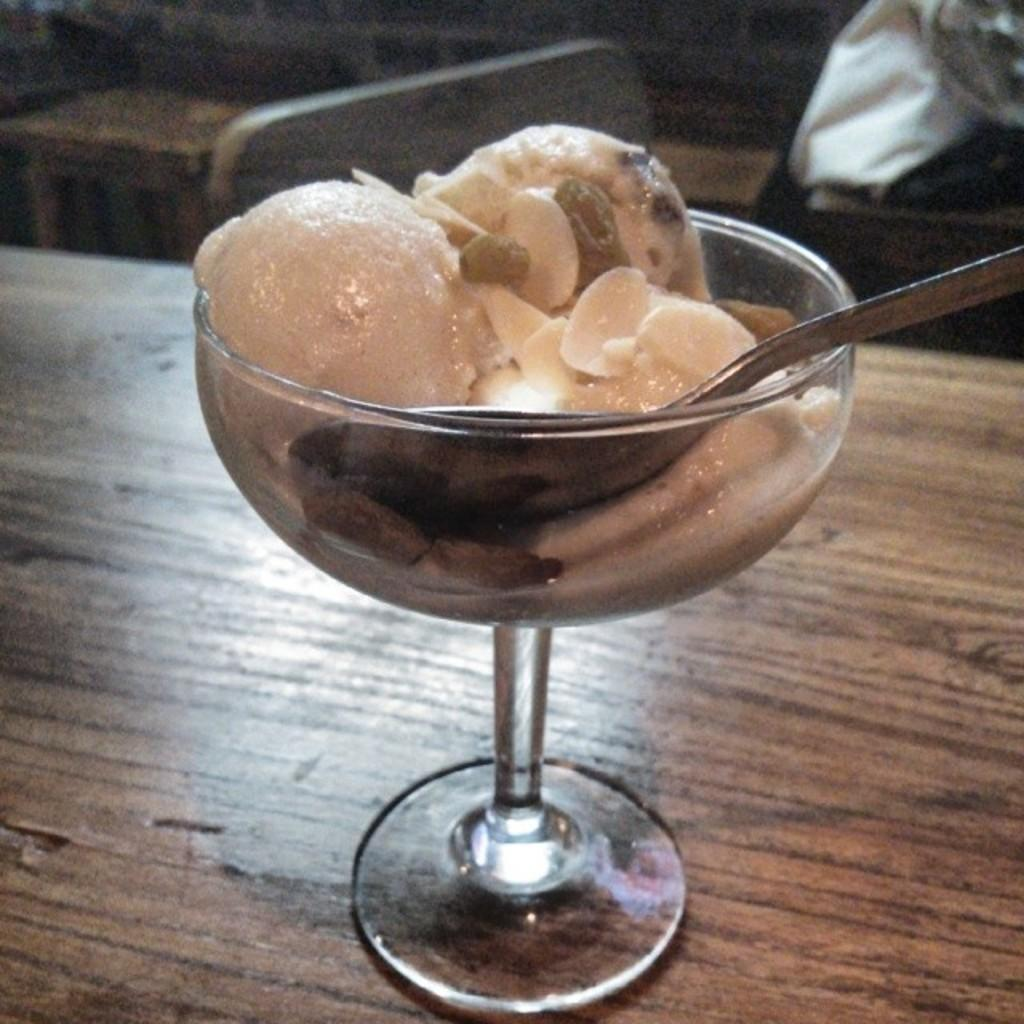What type of dessert is in the image? There is an ice cream in a cup in the image. What utensil is present in the image? There is a spoon in the image. On what surface is the ice cream and spoon placed? The ice cream and spoon are on a wooden table. What can be seen at the top of the image? There are unspecified objects visible at the top of the image. How many horses are present in the image? There are no horses present in the image. What type of fact can be seen in the image? There is no fact visible in the image; it is a photograph of ice cream and a spoon on a wooden table. 